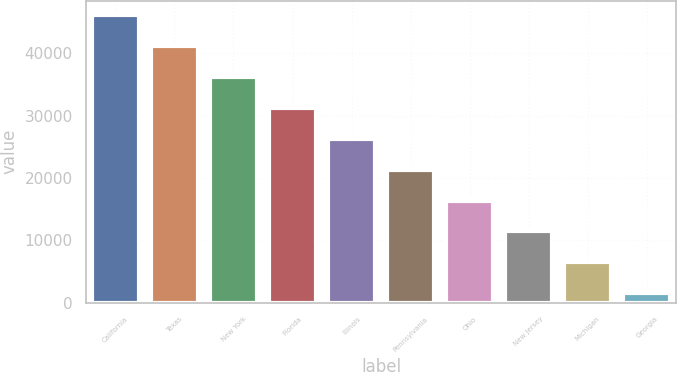Convert chart to OTSL. <chart><loc_0><loc_0><loc_500><loc_500><bar_chart><fcel>California<fcel>Texas<fcel>New York<fcel>Florida<fcel>Illinois<fcel>Pennsylvania<fcel>Ohio<fcel>New Jersey<fcel>Michigan<fcel>Georgia<nl><fcel>46171.4<fcel>41207.8<fcel>36244.2<fcel>31280.6<fcel>26317<fcel>21353.4<fcel>16389.8<fcel>11426.2<fcel>6462.6<fcel>1499<nl></chart> 